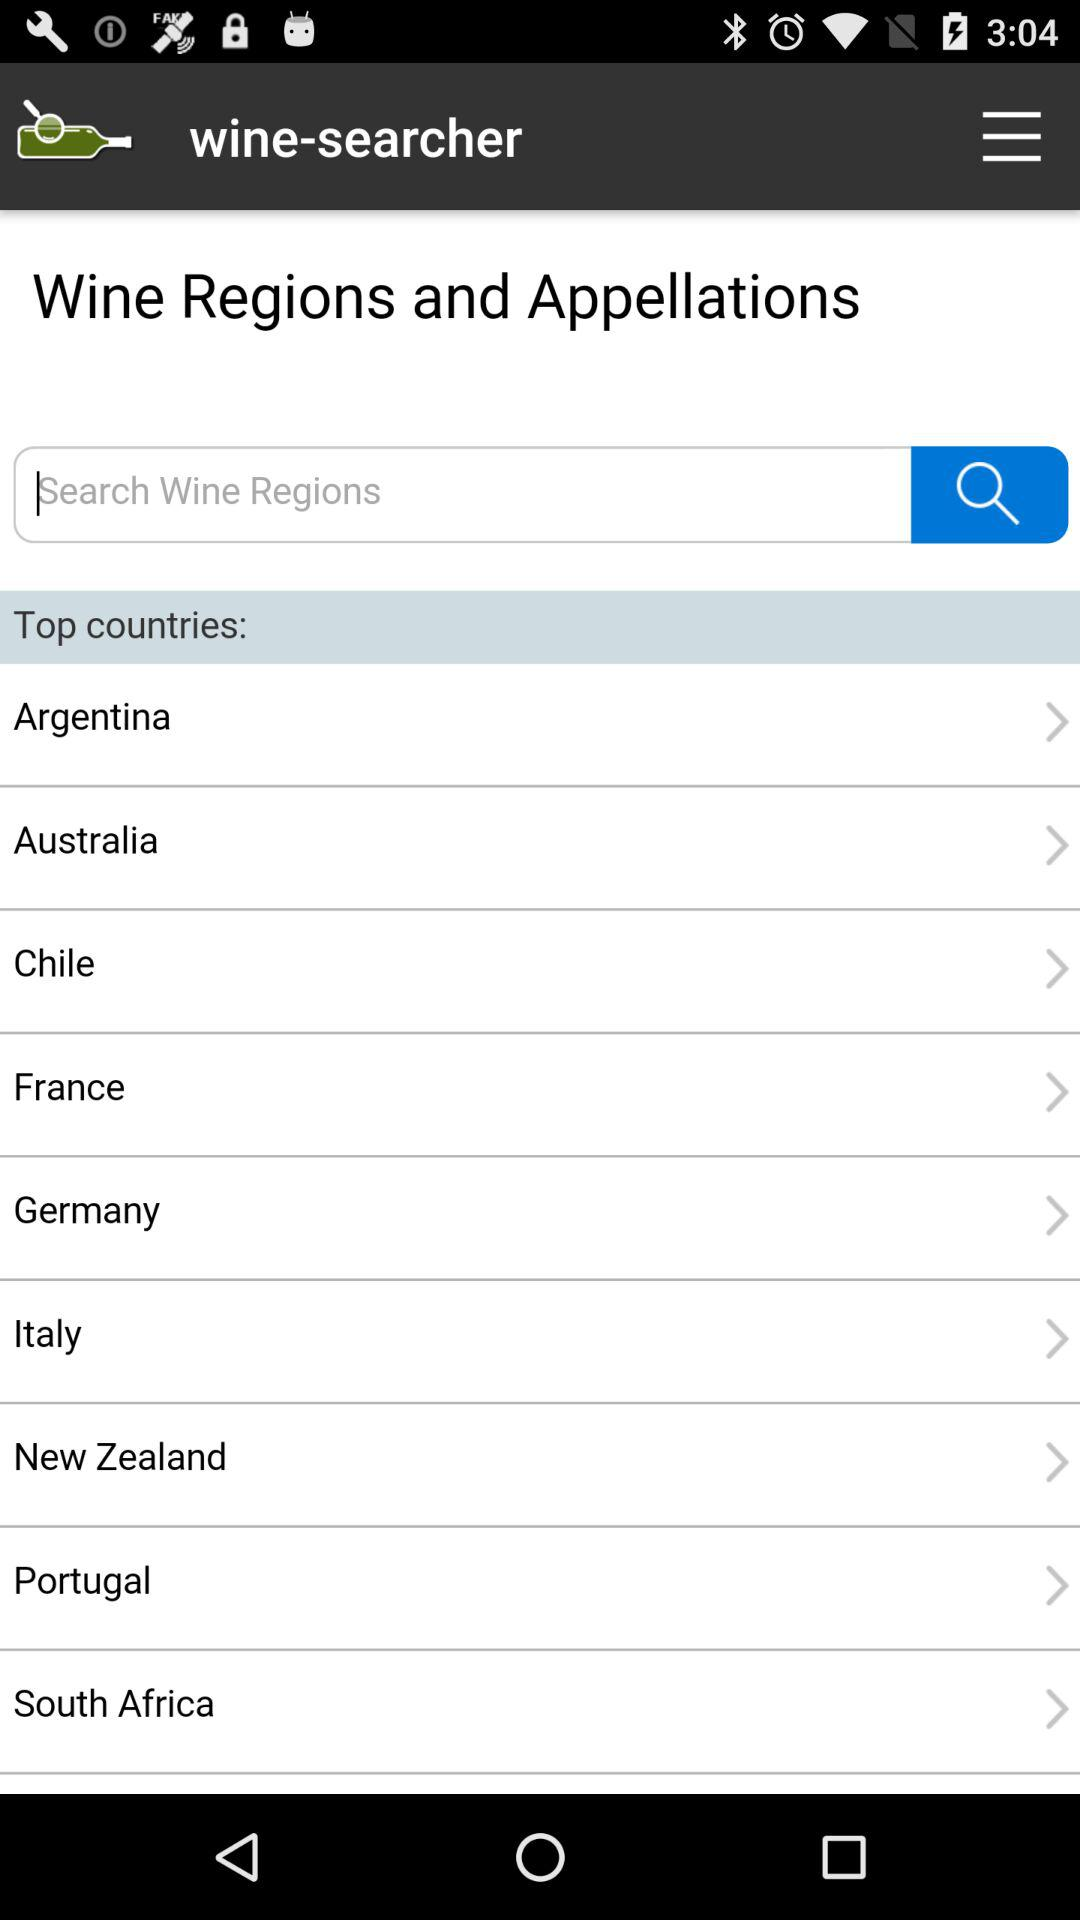What is the name of the application? The name of the application is "wine-searcher". 